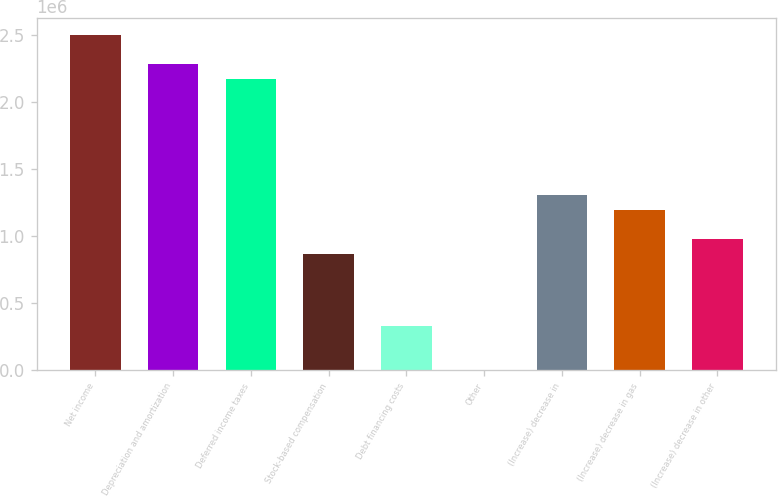<chart> <loc_0><loc_0><loc_500><loc_500><bar_chart><fcel>Net income<fcel>Depreciation and amortization<fcel>Deferred income taxes<fcel>Stock-based compensation<fcel>Debt financing costs<fcel>Other<fcel>(Increase) decrease in<fcel>(Increase) decrease in gas<fcel>(Increase) decrease in other<nl><fcel>2.49866e+06<fcel>2.28147e+06<fcel>2.17288e+06<fcel>869764<fcel>326798<fcel>1019<fcel>1.30414e+06<fcel>1.19554e+06<fcel>978357<nl></chart> 